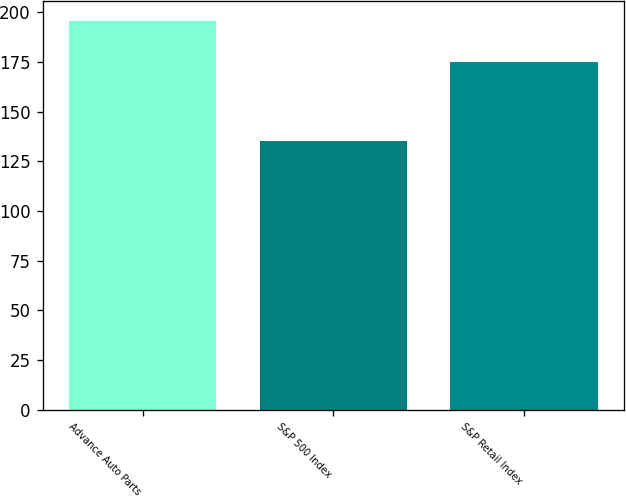Convert chart. <chart><loc_0><loc_0><loc_500><loc_500><bar_chart><fcel>Advance Auto Parts<fcel>S&P 500 Index<fcel>S&P Retail Index<nl><fcel>195.8<fcel>134.97<fcel>174.7<nl></chart> 